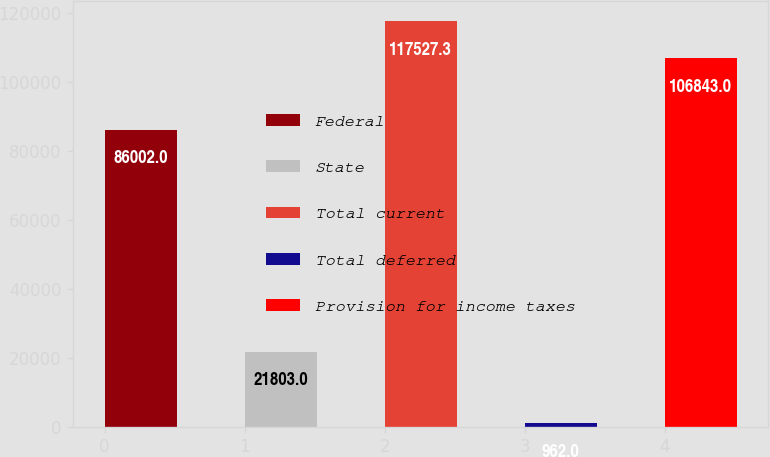<chart> <loc_0><loc_0><loc_500><loc_500><bar_chart><fcel>Federal<fcel>State<fcel>Total current<fcel>Total deferred<fcel>Provision for income taxes<nl><fcel>86002<fcel>21803<fcel>117527<fcel>962<fcel>106843<nl></chart> 